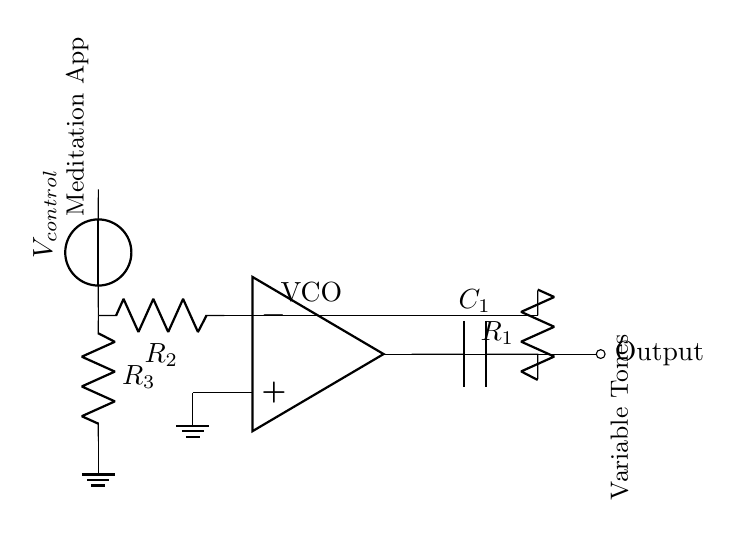What is the component type at the output? The output is connected to an output node labeled as an "ocirc," indicating it's a circuit output connection.
Answer: Output node What components are used in the feedback loop? The feedback loop consists of a capacitor labeled C1 and a resistor labeled R1, both of which connect to the output of the operational amplifier.
Answer: Capacitor and resistor What is the control voltage labeled as? The control voltage in the circuit is labeled as V control, signifying it is the input that will influence the oscillation frequency.
Answer: V control What type of circuit is this described as? This circuit is specifically described as a Voltage-Controlled Oscillator, indicated by the label placed near the operational amplifier.
Answer: Voltage-Controlled Oscillator How many resistors are present in the circuit? There are three resistors in the circuit: R1, R2, and R3, each serving specific roles in the operation of the voltage-controlled oscillator.
Answer: Three What happens at the non-inverting input of the op-amp? The non-inverting input of the op-amp is connected to ground, which typically sets a reference voltage for the operational amplifier.
Answer: Connected to ground What is the purpose of this circuit in meditation apps? The output from this circuit generates variable tones, which are used in meditation apps to create soothing sounds or tones for relaxation.
Answer: Variable tones 